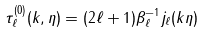Convert formula to latex. <formula><loc_0><loc_0><loc_500><loc_500>\tau _ { \ell } ^ { ( 0 ) } ( k , \eta ) = ( 2 \ell + 1 ) \beta _ { \ell } ^ { - 1 } j _ { \ell } ( k \eta )</formula> 